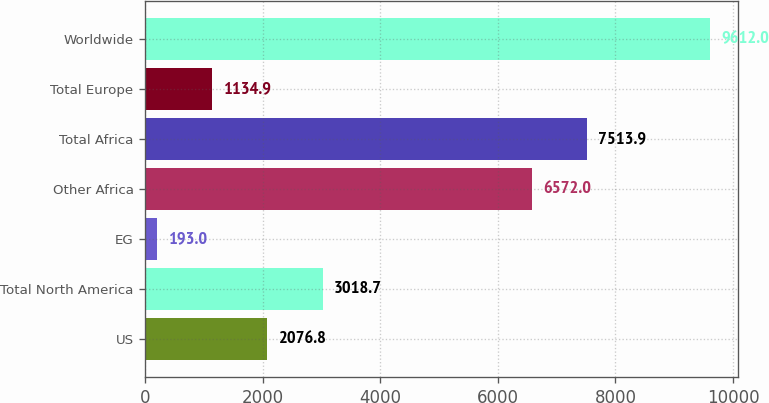<chart> <loc_0><loc_0><loc_500><loc_500><bar_chart><fcel>US<fcel>Total North America<fcel>EG<fcel>Other Africa<fcel>Total Africa<fcel>Total Europe<fcel>Worldwide<nl><fcel>2076.8<fcel>3018.7<fcel>193<fcel>6572<fcel>7513.9<fcel>1134.9<fcel>9612<nl></chart> 